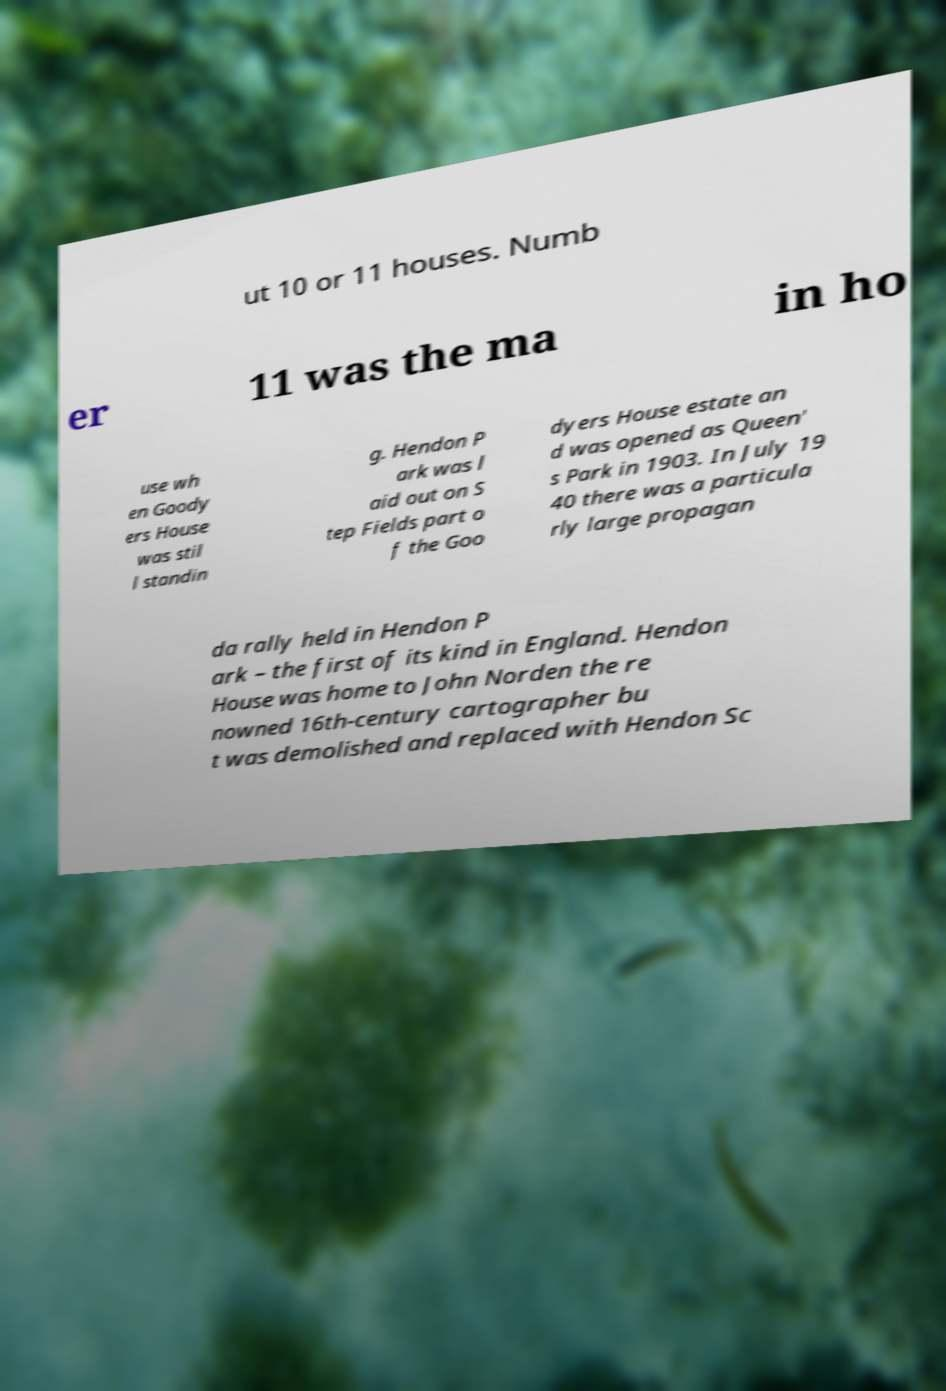Please identify and transcribe the text found in this image. ut 10 or 11 houses. Numb er 11 was the ma in ho use wh en Goody ers House was stil l standin g. Hendon P ark was l aid out on S tep Fields part o f the Goo dyers House estate an d was opened as Queen' s Park in 1903. In July 19 40 there was a particula rly large propagan da rally held in Hendon P ark – the first of its kind in England. Hendon House was home to John Norden the re nowned 16th-century cartographer bu t was demolished and replaced with Hendon Sc 